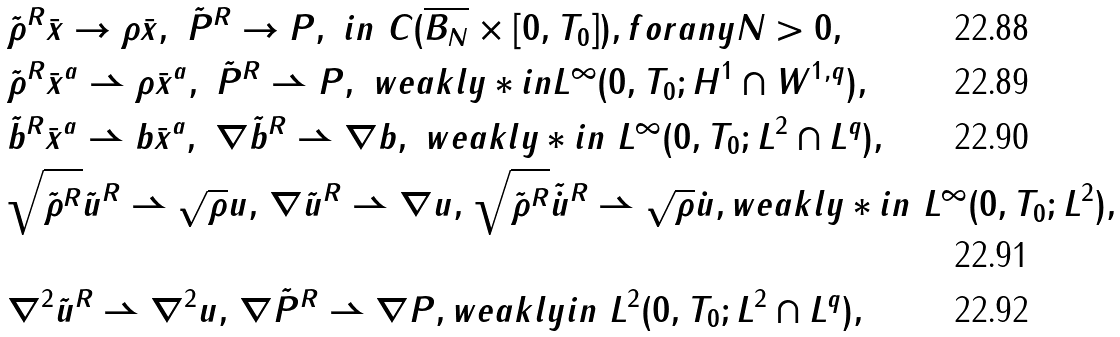Convert formula to latex. <formula><loc_0><loc_0><loc_500><loc_500>& \tilde { \rho } ^ { R } \bar { x } \rightarrow \rho \bar { x } , \ \tilde { P } ^ { R } \rightarrow P , \ i n \ C ( \overline { B _ { N } } \times [ 0 , T _ { 0 } ] ) , f o r a n y N > 0 , \\ & \tilde { \rho } ^ { R } \bar { x } ^ { a } \rightharpoonup \rho \bar { x } ^ { a } , \ \tilde { P } ^ { R } \rightharpoonup P , \ w e a k l y * i n L ^ { \infty } ( 0 , T _ { 0 } ; H ^ { 1 } \cap W ^ { 1 , q } ) , \\ & \tilde { b } ^ { R } \bar { x } ^ { a } \rightharpoonup b \bar { x } ^ { a } , \ \nabla \tilde { b } ^ { R } \rightharpoonup \nabla b , \ w e a k l y * i n \ L ^ { \infty } ( 0 , T _ { 0 } ; L ^ { 2 } \cap L ^ { q } ) , \\ & \sqrt { \tilde { \rho } ^ { R } } \tilde { u } ^ { R } \rightharpoonup \sqrt { \rho } u , \, \nabla \tilde { u } ^ { R } \rightharpoonup \nabla u , \, \sqrt { \tilde { \rho } ^ { R } } \tilde { \dot { u } } ^ { R } \rightharpoonup \sqrt { \rho } \dot { u } , w e a k l y * i n \ L ^ { \infty } ( 0 , T _ { 0 } ; L ^ { 2 } ) , \\ & \nabla ^ { 2 } \tilde { u } ^ { R } \rightharpoonup \nabla ^ { 2 } u , \, \nabla \tilde { P } ^ { R } \rightharpoonup \nabla P , w e a k l y i n \ L ^ { 2 } ( 0 , T _ { 0 } ; L ^ { 2 } \cap L ^ { q } ) ,</formula> 